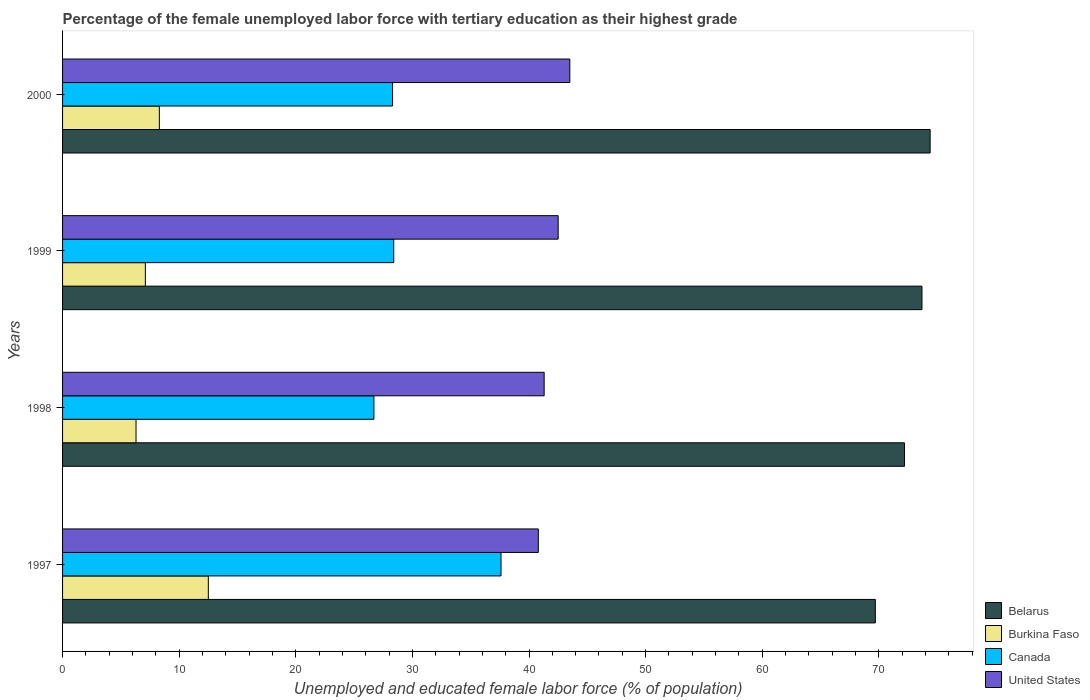How many different coloured bars are there?
Your response must be concise. 4. What is the percentage of the unemployed female labor force with tertiary education in Canada in 1998?
Keep it short and to the point. 26.7. Across all years, what is the maximum percentage of the unemployed female labor force with tertiary education in Canada?
Your response must be concise. 37.6. Across all years, what is the minimum percentage of the unemployed female labor force with tertiary education in Canada?
Ensure brevity in your answer.  26.7. What is the total percentage of the unemployed female labor force with tertiary education in United States in the graph?
Offer a terse response. 168.1. What is the difference between the percentage of the unemployed female labor force with tertiary education in Belarus in 1998 and that in 2000?
Ensure brevity in your answer.  -2.2. What is the difference between the percentage of the unemployed female labor force with tertiary education in United States in 2000 and the percentage of the unemployed female labor force with tertiary education in Burkina Faso in 1999?
Keep it short and to the point. 36.4. What is the average percentage of the unemployed female labor force with tertiary education in Canada per year?
Make the answer very short. 30.25. In the year 2000, what is the difference between the percentage of the unemployed female labor force with tertiary education in Burkina Faso and percentage of the unemployed female labor force with tertiary education in United States?
Your response must be concise. -35.2. In how many years, is the percentage of the unemployed female labor force with tertiary education in United States greater than 2 %?
Your answer should be very brief. 4. What is the ratio of the percentage of the unemployed female labor force with tertiary education in United States in 1997 to that in 1999?
Provide a succinct answer. 0.96. Is the percentage of the unemployed female labor force with tertiary education in United States in 1998 less than that in 2000?
Your answer should be compact. Yes. Is the difference between the percentage of the unemployed female labor force with tertiary education in Burkina Faso in 1997 and 2000 greater than the difference between the percentage of the unemployed female labor force with tertiary education in United States in 1997 and 2000?
Your answer should be compact. Yes. What is the difference between the highest and the second highest percentage of the unemployed female labor force with tertiary education in Belarus?
Your answer should be compact. 0.7. What is the difference between the highest and the lowest percentage of the unemployed female labor force with tertiary education in United States?
Offer a very short reply. 2.7. What does the 4th bar from the top in 2000 represents?
Your answer should be very brief. Belarus. What does the 1st bar from the bottom in 1997 represents?
Keep it short and to the point. Belarus. How many bars are there?
Ensure brevity in your answer.  16. Are all the bars in the graph horizontal?
Your answer should be very brief. Yes. How many years are there in the graph?
Offer a very short reply. 4. What is the difference between two consecutive major ticks on the X-axis?
Make the answer very short. 10. Are the values on the major ticks of X-axis written in scientific E-notation?
Provide a succinct answer. No. Does the graph contain any zero values?
Give a very brief answer. No. Does the graph contain grids?
Make the answer very short. No. What is the title of the graph?
Your answer should be compact. Percentage of the female unemployed labor force with tertiary education as their highest grade. What is the label or title of the X-axis?
Your answer should be very brief. Unemployed and educated female labor force (% of population). What is the Unemployed and educated female labor force (% of population) in Belarus in 1997?
Your answer should be compact. 69.7. What is the Unemployed and educated female labor force (% of population) in Canada in 1997?
Make the answer very short. 37.6. What is the Unemployed and educated female labor force (% of population) in United States in 1997?
Your response must be concise. 40.8. What is the Unemployed and educated female labor force (% of population) of Belarus in 1998?
Your response must be concise. 72.2. What is the Unemployed and educated female labor force (% of population) in Burkina Faso in 1998?
Offer a very short reply. 6.3. What is the Unemployed and educated female labor force (% of population) of Canada in 1998?
Offer a very short reply. 26.7. What is the Unemployed and educated female labor force (% of population) of United States in 1998?
Your response must be concise. 41.3. What is the Unemployed and educated female labor force (% of population) in Belarus in 1999?
Your response must be concise. 73.7. What is the Unemployed and educated female labor force (% of population) of Burkina Faso in 1999?
Your answer should be very brief. 7.1. What is the Unemployed and educated female labor force (% of population) in Canada in 1999?
Make the answer very short. 28.4. What is the Unemployed and educated female labor force (% of population) in United States in 1999?
Your answer should be very brief. 42.5. What is the Unemployed and educated female labor force (% of population) of Belarus in 2000?
Offer a very short reply. 74.4. What is the Unemployed and educated female labor force (% of population) of Burkina Faso in 2000?
Your answer should be compact. 8.3. What is the Unemployed and educated female labor force (% of population) in Canada in 2000?
Give a very brief answer. 28.3. What is the Unemployed and educated female labor force (% of population) in United States in 2000?
Make the answer very short. 43.5. Across all years, what is the maximum Unemployed and educated female labor force (% of population) in Belarus?
Your answer should be very brief. 74.4. Across all years, what is the maximum Unemployed and educated female labor force (% of population) in Canada?
Offer a terse response. 37.6. Across all years, what is the maximum Unemployed and educated female labor force (% of population) of United States?
Ensure brevity in your answer.  43.5. Across all years, what is the minimum Unemployed and educated female labor force (% of population) of Belarus?
Your answer should be very brief. 69.7. Across all years, what is the minimum Unemployed and educated female labor force (% of population) of Burkina Faso?
Your answer should be very brief. 6.3. Across all years, what is the minimum Unemployed and educated female labor force (% of population) in Canada?
Provide a short and direct response. 26.7. Across all years, what is the minimum Unemployed and educated female labor force (% of population) of United States?
Provide a succinct answer. 40.8. What is the total Unemployed and educated female labor force (% of population) in Belarus in the graph?
Offer a very short reply. 290. What is the total Unemployed and educated female labor force (% of population) in Burkina Faso in the graph?
Make the answer very short. 34.2. What is the total Unemployed and educated female labor force (% of population) of Canada in the graph?
Keep it short and to the point. 121. What is the total Unemployed and educated female labor force (% of population) of United States in the graph?
Provide a short and direct response. 168.1. What is the difference between the Unemployed and educated female labor force (% of population) in Belarus in 1997 and that in 1998?
Keep it short and to the point. -2.5. What is the difference between the Unemployed and educated female labor force (% of population) in Burkina Faso in 1997 and that in 1998?
Your answer should be compact. 6.2. What is the difference between the Unemployed and educated female labor force (% of population) of Canada in 1997 and that in 1998?
Offer a very short reply. 10.9. What is the difference between the Unemployed and educated female labor force (% of population) in United States in 1997 and that in 1998?
Keep it short and to the point. -0.5. What is the difference between the Unemployed and educated female labor force (% of population) of Burkina Faso in 1997 and that in 1999?
Keep it short and to the point. 5.4. What is the difference between the Unemployed and educated female labor force (% of population) of Belarus in 1997 and that in 2000?
Provide a succinct answer. -4.7. What is the difference between the Unemployed and educated female labor force (% of population) in Canada in 1997 and that in 2000?
Keep it short and to the point. 9.3. What is the difference between the Unemployed and educated female labor force (% of population) of Belarus in 1998 and that in 1999?
Your answer should be very brief. -1.5. What is the difference between the Unemployed and educated female labor force (% of population) in United States in 1998 and that in 1999?
Make the answer very short. -1.2. What is the difference between the Unemployed and educated female labor force (% of population) of Canada in 1998 and that in 2000?
Provide a succinct answer. -1.6. What is the difference between the Unemployed and educated female labor force (% of population) of Canada in 1999 and that in 2000?
Give a very brief answer. 0.1. What is the difference between the Unemployed and educated female labor force (% of population) in United States in 1999 and that in 2000?
Provide a succinct answer. -1. What is the difference between the Unemployed and educated female labor force (% of population) in Belarus in 1997 and the Unemployed and educated female labor force (% of population) in Burkina Faso in 1998?
Your answer should be very brief. 63.4. What is the difference between the Unemployed and educated female labor force (% of population) in Belarus in 1997 and the Unemployed and educated female labor force (% of population) in United States in 1998?
Ensure brevity in your answer.  28.4. What is the difference between the Unemployed and educated female labor force (% of population) of Burkina Faso in 1997 and the Unemployed and educated female labor force (% of population) of United States in 1998?
Offer a terse response. -28.8. What is the difference between the Unemployed and educated female labor force (% of population) in Belarus in 1997 and the Unemployed and educated female labor force (% of population) in Burkina Faso in 1999?
Your answer should be very brief. 62.6. What is the difference between the Unemployed and educated female labor force (% of population) in Belarus in 1997 and the Unemployed and educated female labor force (% of population) in Canada in 1999?
Your answer should be very brief. 41.3. What is the difference between the Unemployed and educated female labor force (% of population) in Belarus in 1997 and the Unemployed and educated female labor force (% of population) in United States in 1999?
Your response must be concise. 27.2. What is the difference between the Unemployed and educated female labor force (% of population) in Burkina Faso in 1997 and the Unemployed and educated female labor force (% of population) in Canada in 1999?
Make the answer very short. -15.9. What is the difference between the Unemployed and educated female labor force (% of population) in Belarus in 1997 and the Unemployed and educated female labor force (% of population) in Burkina Faso in 2000?
Offer a terse response. 61.4. What is the difference between the Unemployed and educated female labor force (% of population) of Belarus in 1997 and the Unemployed and educated female labor force (% of population) of Canada in 2000?
Provide a short and direct response. 41.4. What is the difference between the Unemployed and educated female labor force (% of population) in Belarus in 1997 and the Unemployed and educated female labor force (% of population) in United States in 2000?
Keep it short and to the point. 26.2. What is the difference between the Unemployed and educated female labor force (% of population) of Burkina Faso in 1997 and the Unemployed and educated female labor force (% of population) of Canada in 2000?
Offer a very short reply. -15.8. What is the difference between the Unemployed and educated female labor force (% of population) in Burkina Faso in 1997 and the Unemployed and educated female labor force (% of population) in United States in 2000?
Your response must be concise. -31. What is the difference between the Unemployed and educated female labor force (% of population) in Belarus in 1998 and the Unemployed and educated female labor force (% of population) in Burkina Faso in 1999?
Keep it short and to the point. 65.1. What is the difference between the Unemployed and educated female labor force (% of population) of Belarus in 1998 and the Unemployed and educated female labor force (% of population) of Canada in 1999?
Ensure brevity in your answer.  43.8. What is the difference between the Unemployed and educated female labor force (% of population) of Belarus in 1998 and the Unemployed and educated female labor force (% of population) of United States in 1999?
Make the answer very short. 29.7. What is the difference between the Unemployed and educated female labor force (% of population) in Burkina Faso in 1998 and the Unemployed and educated female labor force (% of population) in Canada in 1999?
Keep it short and to the point. -22.1. What is the difference between the Unemployed and educated female labor force (% of population) of Burkina Faso in 1998 and the Unemployed and educated female labor force (% of population) of United States in 1999?
Your answer should be very brief. -36.2. What is the difference between the Unemployed and educated female labor force (% of population) in Canada in 1998 and the Unemployed and educated female labor force (% of population) in United States in 1999?
Give a very brief answer. -15.8. What is the difference between the Unemployed and educated female labor force (% of population) in Belarus in 1998 and the Unemployed and educated female labor force (% of population) in Burkina Faso in 2000?
Keep it short and to the point. 63.9. What is the difference between the Unemployed and educated female labor force (% of population) in Belarus in 1998 and the Unemployed and educated female labor force (% of population) in Canada in 2000?
Keep it short and to the point. 43.9. What is the difference between the Unemployed and educated female labor force (% of population) in Belarus in 1998 and the Unemployed and educated female labor force (% of population) in United States in 2000?
Your answer should be very brief. 28.7. What is the difference between the Unemployed and educated female labor force (% of population) in Burkina Faso in 1998 and the Unemployed and educated female labor force (% of population) in Canada in 2000?
Offer a terse response. -22. What is the difference between the Unemployed and educated female labor force (% of population) of Burkina Faso in 1998 and the Unemployed and educated female labor force (% of population) of United States in 2000?
Offer a very short reply. -37.2. What is the difference between the Unemployed and educated female labor force (% of population) in Canada in 1998 and the Unemployed and educated female labor force (% of population) in United States in 2000?
Make the answer very short. -16.8. What is the difference between the Unemployed and educated female labor force (% of population) in Belarus in 1999 and the Unemployed and educated female labor force (% of population) in Burkina Faso in 2000?
Give a very brief answer. 65.4. What is the difference between the Unemployed and educated female labor force (% of population) of Belarus in 1999 and the Unemployed and educated female labor force (% of population) of Canada in 2000?
Give a very brief answer. 45.4. What is the difference between the Unemployed and educated female labor force (% of population) in Belarus in 1999 and the Unemployed and educated female labor force (% of population) in United States in 2000?
Your response must be concise. 30.2. What is the difference between the Unemployed and educated female labor force (% of population) of Burkina Faso in 1999 and the Unemployed and educated female labor force (% of population) of Canada in 2000?
Your answer should be compact. -21.2. What is the difference between the Unemployed and educated female labor force (% of population) in Burkina Faso in 1999 and the Unemployed and educated female labor force (% of population) in United States in 2000?
Keep it short and to the point. -36.4. What is the difference between the Unemployed and educated female labor force (% of population) of Canada in 1999 and the Unemployed and educated female labor force (% of population) of United States in 2000?
Make the answer very short. -15.1. What is the average Unemployed and educated female labor force (% of population) in Belarus per year?
Make the answer very short. 72.5. What is the average Unemployed and educated female labor force (% of population) in Burkina Faso per year?
Make the answer very short. 8.55. What is the average Unemployed and educated female labor force (% of population) of Canada per year?
Your response must be concise. 30.25. What is the average Unemployed and educated female labor force (% of population) in United States per year?
Keep it short and to the point. 42.02. In the year 1997, what is the difference between the Unemployed and educated female labor force (% of population) of Belarus and Unemployed and educated female labor force (% of population) of Burkina Faso?
Offer a terse response. 57.2. In the year 1997, what is the difference between the Unemployed and educated female labor force (% of population) in Belarus and Unemployed and educated female labor force (% of population) in Canada?
Provide a short and direct response. 32.1. In the year 1997, what is the difference between the Unemployed and educated female labor force (% of population) of Belarus and Unemployed and educated female labor force (% of population) of United States?
Offer a terse response. 28.9. In the year 1997, what is the difference between the Unemployed and educated female labor force (% of population) of Burkina Faso and Unemployed and educated female labor force (% of population) of Canada?
Give a very brief answer. -25.1. In the year 1997, what is the difference between the Unemployed and educated female labor force (% of population) of Burkina Faso and Unemployed and educated female labor force (% of population) of United States?
Offer a very short reply. -28.3. In the year 1997, what is the difference between the Unemployed and educated female labor force (% of population) in Canada and Unemployed and educated female labor force (% of population) in United States?
Offer a very short reply. -3.2. In the year 1998, what is the difference between the Unemployed and educated female labor force (% of population) of Belarus and Unemployed and educated female labor force (% of population) of Burkina Faso?
Offer a very short reply. 65.9. In the year 1998, what is the difference between the Unemployed and educated female labor force (% of population) of Belarus and Unemployed and educated female labor force (% of population) of Canada?
Your answer should be very brief. 45.5. In the year 1998, what is the difference between the Unemployed and educated female labor force (% of population) in Belarus and Unemployed and educated female labor force (% of population) in United States?
Your answer should be very brief. 30.9. In the year 1998, what is the difference between the Unemployed and educated female labor force (% of population) in Burkina Faso and Unemployed and educated female labor force (% of population) in Canada?
Keep it short and to the point. -20.4. In the year 1998, what is the difference between the Unemployed and educated female labor force (% of population) of Burkina Faso and Unemployed and educated female labor force (% of population) of United States?
Your answer should be very brief. -35. In the year 1998, what is the difference between the Unemployed and educated female labor force (% of population) in Canada and Unemployed and educated female labor force (% of population) in United States?
Your response must be concise. -14.6. In the year 1999, what is the difference between the Unemployed and educated female labor force (% of population) of Belarus and Unemployed and educated female labor force (% of population) of Burkina Faso?
Your answer should be compact. 66.6. In the year 1999, what is the difference between the Unemployed and educated female labor force (% of population) in Belarus and Unemployed and educated female labor force (% of population) in Canada?
Your answer should be very brief. 45.3. In the year 1999, what is the difference between the Unemployed and educated female labor force (% of population) in Belarus and Unemployed and educated female labor force (% of population) in United States?
Keep it short and to the point. 31.2. In the year 1999, what is the difference between the Unemployed and educated female labor force (% of population) of Burkina Faso and Unemployed and educated female labor force (% of population) of Canada?
Give a very brief answer. -21.3. In the year 1999, what is the difference between the Unemployed and educated female labor force (% of population) of Burkina Faso and Unemployed and educated female labor force (% of population) of United States?
Ensure brevity in your answer.  -35.4. In the year 1999, what is the difference between the Unemployed and educated female labor force (% of population) in Canada and Unemployed and educated female labor force (% of population) in United States?
Offer a very short reply. -14.1. In the year 2000, what is the difference between the Unemployed and educated female labor force (% of population) in Belarus and Unemployed and educated female labor force (% of population) in Burkina Faso?
Your response must be concise. 66.1. In the year 2000, what is the difference between the Unemployed and educated female labor force (% of population) in Belarus and Unemployed and educated female labor force (% of population) in Canada?
Make the answer very short. 46.1. In the year 2000, what is the difference between the Unemployed and educated female labor force (% of population) of Belarus and Unemployed and educated female labor force (% of population) of United States?
Make the answer very short. 30.9. In the year 2000, what is the difference between the Unemployed and educated female labor force (% of population) of Burkina Faso and Unemployed and educated female labor force (% of population) of United States?
Provide a short and direct response. -35.2. In the year 2000, what is the difference between the Unemployed and educated female labor force (% of population) of Canada and Unemployed and educated female labor force (% of population) of United States?
Offer a terse response. -15.2. What is the ratio of the Unemployed and educated female labor force (% of population) in Belarus in 1997 to that in 1998?
Your answer should be compact. 0.97. What is the ratio of the Unemployed and educated female labor force (% of population) in Burkina Faso in 1997 to that in 1998?
Keep it short and to the point. 1.98. What is the ratio of the Unemployed and educated female labor force (% of population) of Canada in 1997 to that in 1998?
Make the answer very short. 1.41. What is the ratio of the Unemployed and educated female labor force (% of population) of United States in 1997 to that in 1998?
Make the answer very short. 0.99. What is the ratio of the Unemployed and educated female labor force (% of population) in Belarus in 1997 to that in 1999?
Offer a terse response. 0.95. What is the ratio of the Unemployed and educated female labor force (% of population) of Burkina Faso in 1997 to that in 1999?
Your answer should be compact. 1.76. What is the ratio of the Unemployed and educated female labor force (% of population) in Canada in 1997 to that in 1999?
Provide a short and direct response. 1.32. What is the ratio of the Unemployed and educated female labor force (% of population) of United States in 1997 to that in 1999?
Make the answer very short. 0.96. What is the ratio of the Unemployed and educated female labor force (% of population) in Belarus in 1997 to that in 2000?
Your answer should be compact. 0.94. What is the ratio of the Unemployed and educated female labor force (% of population) in Burkina Faso in 1997 to that in 2000?
Provide a succinct answer. 1.51. What is the ratio of the Unemployed and educated female labor force (% of population) in Canada in 1997 to that in 2000?
Provide a succinct answer. 1.33. What is the ratio of the Unemployed and educated female labor force (% of population) in United States in 1997 to that in 2000?
Make the answer very short. 0.94. What is the ratio of the Unemployed and educated female labor force (% of population) of Belarus in 1998 to that in 1999?
Provide a short and direct response. 0.98. What is the ratio of the Unemployed and educated female labor force (% of population) in Burkina Faso in 1998 to that in 1999?
Ensure brevity in your answer.  0.89. What is the ratio of the Unemployed and educated female labor force (% of population) in Canada in 1998 to that in 1999?
Offer a very short reply. 0.94. What is the ratio of the Unemployed and educated female labor force (% of population) of United States in 1998 to that in 1999?
Keep it short and to the point. 0.97. What is the ratio of the Unemployed and educated female labor force (% of population) of Belarus in 1998 to that in 2000?
Offer a terse response. 0.97. What is the ratio of the Unemployed and educated female labor force (% of population) in Burkina Faso in 1998 to that in 2000?
Your answer should be compact. 0.76. What is the ratio of the Unemployed and educated female labor force (% of population) in Canada in 1998 to that in 2000?
Your answer should be very brief. 0.94. What is the ratio of the Unemployed and educated female labor force (% of population) of United States in 1998 to that in 2000?
Offer a very short reply. 0.95. What is the ratio of the Unemployed and educated female labor force (% of population) in Belarus in 1999 to that in 2000?
Your answer should be very brief. 0.99. What is the ratio of the Unemployed and educated female labor force (% of population) of Burkina Faso in 1999 to that in 2000?
Provide a succinct answer. 0.86. What is the difference between the highest and the second highest Unemployed and educated female labor force (% of population) in Belarus?
Your answer should be compact. 0.7. What is the difference between the highest and the second highest Unemployed and educated female labor force (% of population) of Burkina Faso?
Provide a short and direct response. 4.2. What is the difference between the highest and the lowest Unemployed and educated female labor force (% of population) of Burkina Faso?
Make the answer very short. 6.2. 